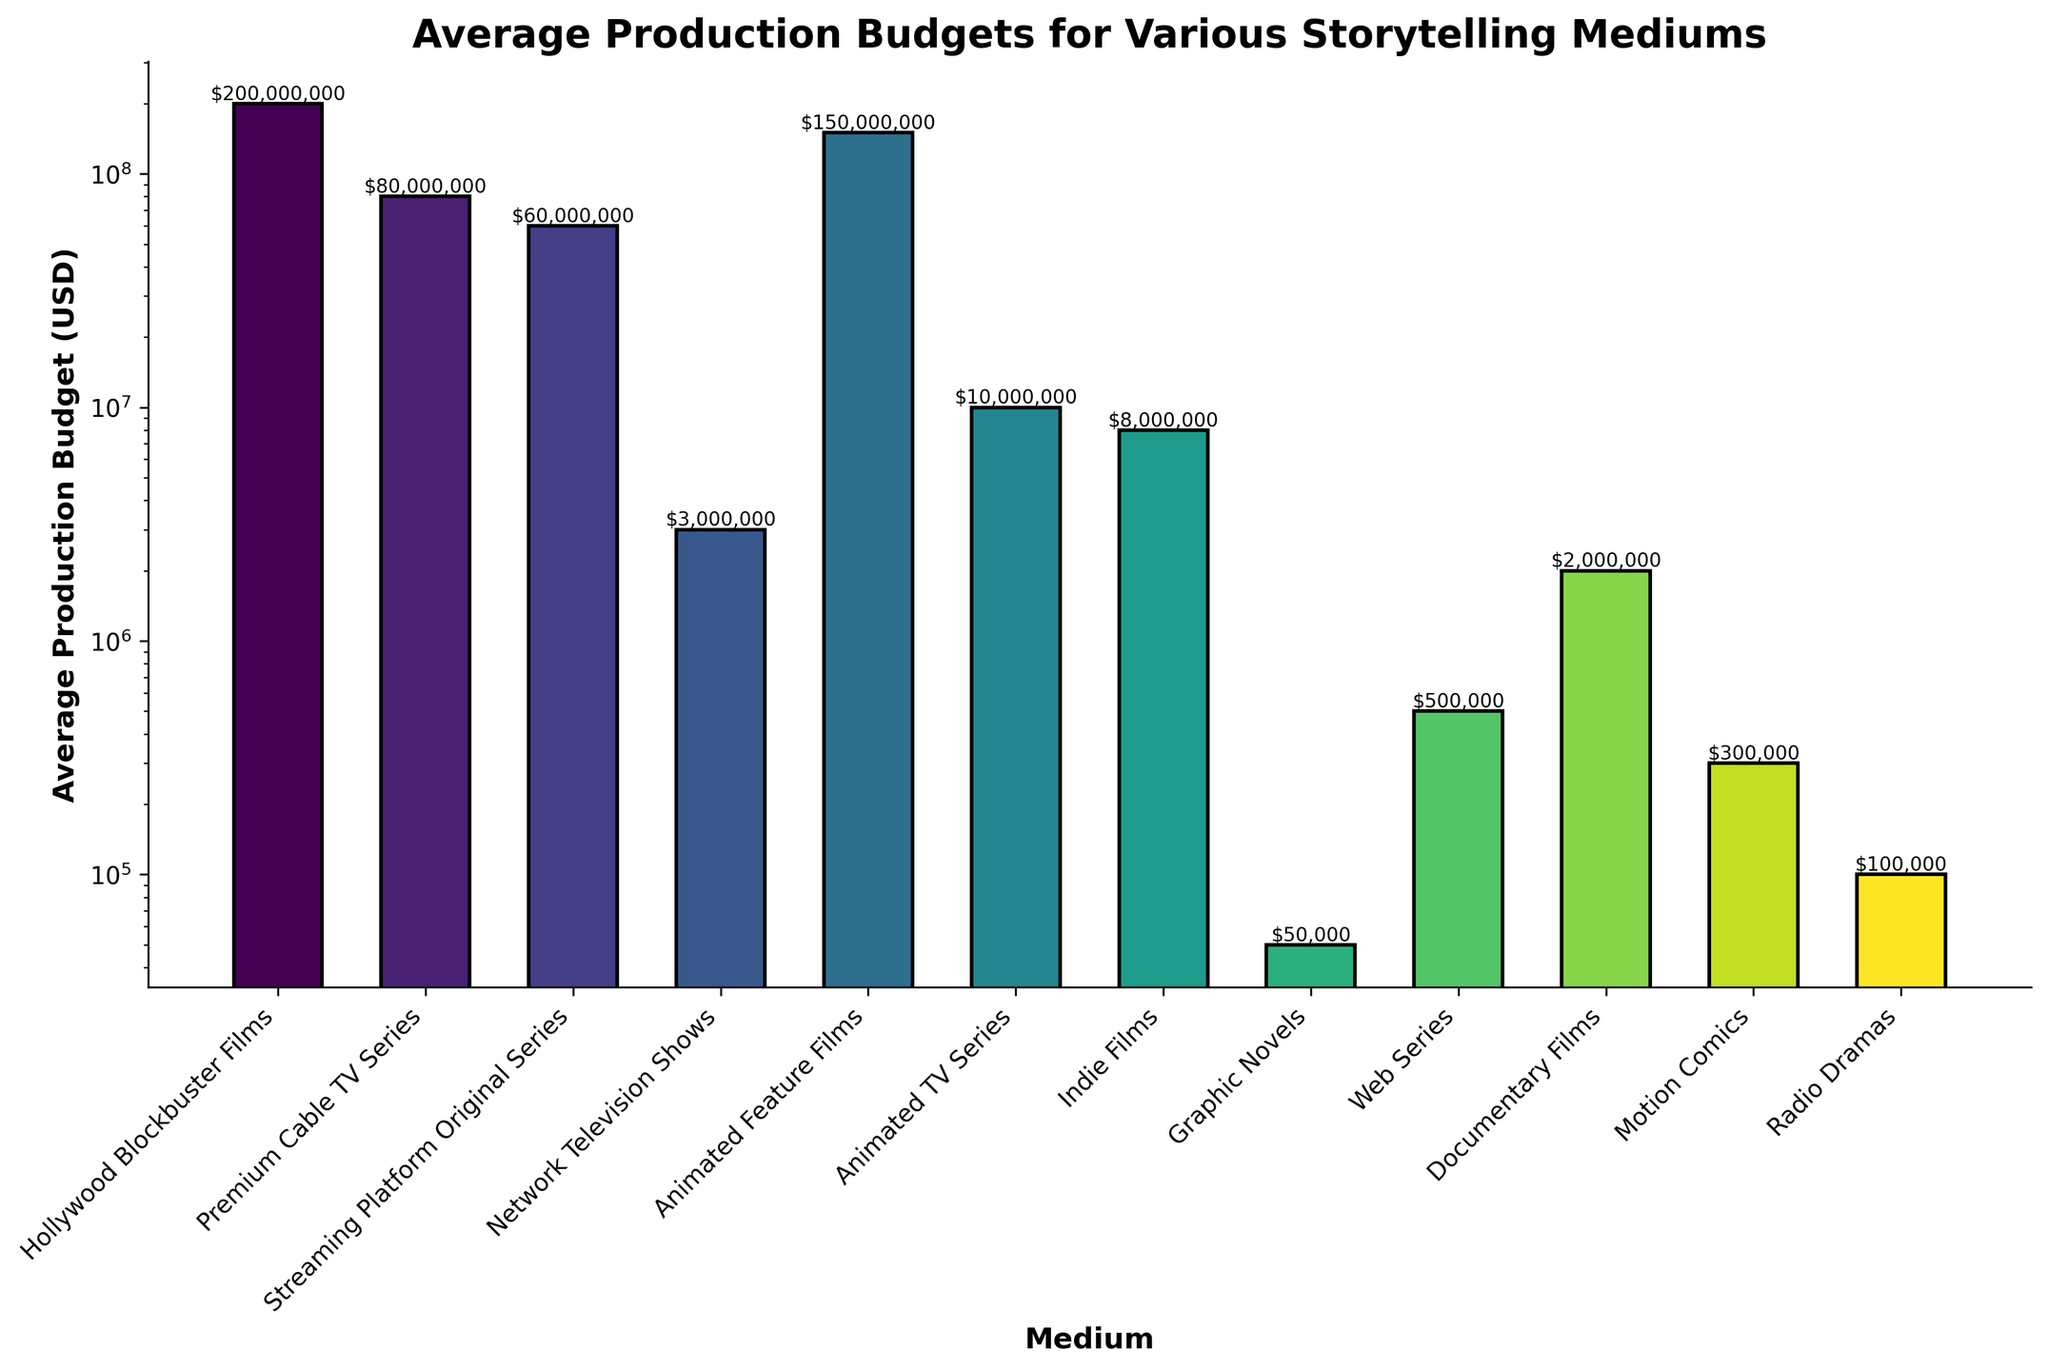Which storytelling medium has the highest average production budget? By looking at the heights of the bars, the highest one represents Hollywood Blockbuster Films.
Answer: Hollywood Blockbuster Films Which storytelling medium has the lowest average production budget? By observing the shortest bar, it represents Radio Dramas.
Answer: Radio Dramas How much more is the average production budget for Animated Feature Films compared to Graphic Novels? Take the average budget for Animated Feature Films ($150,000,000) and subtract the average budget for Graphic Novels ($50,000). Thus, the difference is $150,000,000 - $50,000.
Answer: $149,950,000 Which has a larger average production budget, Network Television Shows or Indie Films? By comparing the heights of the bars, Network Television Shows has a budget of $3,000,000, while Indie Films have a budget of $8,000,000. Indie Films have a larger budget.
Answer: Indie Films Order the storytelling mediums by average production budget in descending order. Read the heights of the bars and list them from highest to lowest: Hollywood Blockbuster Films, Animated Feature Films, Premium Cable TV Series, Streaming Platform Original Series, Animated TV Series, Indie Films, Network Television Shows, Documentary Films, Web Series, Motion Comics, Radio Dramas, Graphic Novels.
Answer: Hollywood Blockbuster Films, Animated Feature Films, Premium Cable TV Series, Streaming Platform Original Series, Animated TV Series, Indie Films, Network Television Shows, Documentary Films, Web Series, Motion Comics, Radio Dramas, Graphic Novels What is the average production budget for the top three most expensive storytelling mediums combined? Sum the average budgets of Hollywood Blockbuster Films ($200,000,000), Animated Feature Films ($150,000,000), and Premium Cable TV Series ($80,000,000). The total is $200,000,000 + $150,000,000 + $80,000,000.
Answer: $430,000,000 Compare the average production budget of Network Television Shows to Web Series. Which one is higher and by how much? The average budget for Network Television Shows is $3,000,000, while Web Series have a budget of $500,000. The difference is $3,000,000 - $500,000. Network Television Shows are higher by $2,500,000.
Answer: $2,500,000 How many mediums have an average production budget of less than $10,000,000? Identify and count the bars with heights representing less than $10,000,000. These are Web Series, Documentary Films, Motion Comics, Radio Dramas, and Graphic Novels, totaling five mediums.
Answer: 5 What is the median average production budget of all the storytelling mediums? List all the average production budgets in ascending order: $50,000, $100,000, $300,000, $500,000, $2,000,000, $3,000,000, $8,000,000, $10,000,000, $60,000,000, $80,000,000, $150,000,000, $200,000,000. The median is the average of the middle two values, which are $8,000,000 and $10,000,000. So, the median is ($8,000,000 + $10,000,000) / 2.
Answer: $9,000,000 